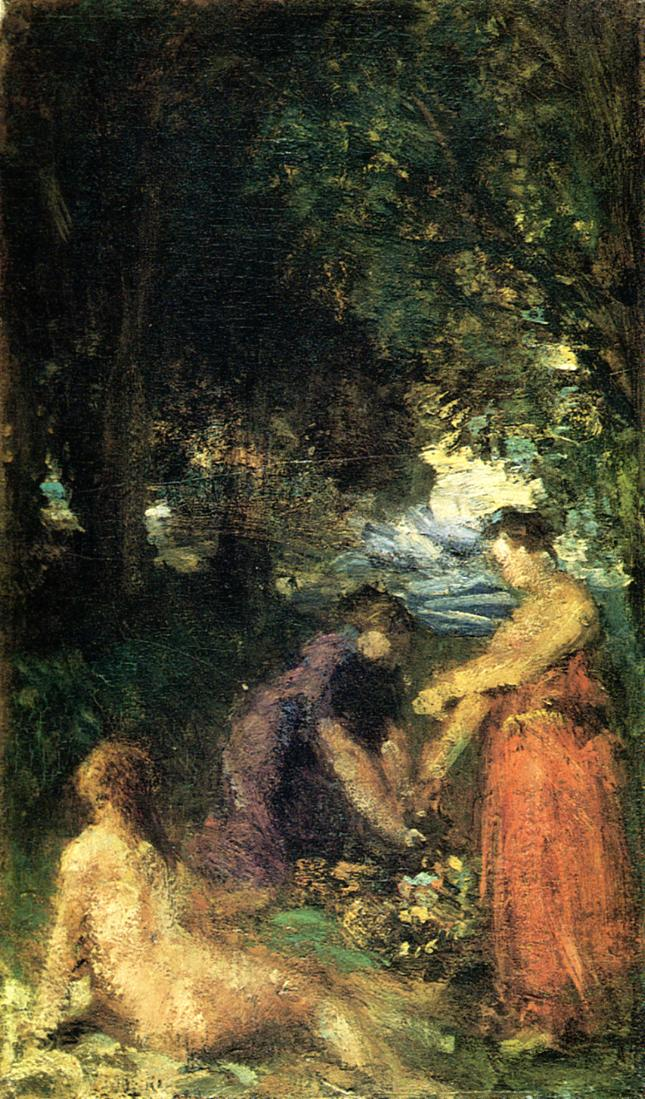What do you think the figures in the painting are doing? It appears that the figures in the painting are engaged in a communal activity, possibly gathering or arranging flowers in the forest. The figure on the left seems to be reclining and observing the scene, while the two central figures are more actively involved in the task. The figure on the right, dressed in warm colors, extends their arms towards the central arrangement, suggesting a collaborative effort. This interpretation adds to the sense of camaraderie and shared experience depicted in the painting. 